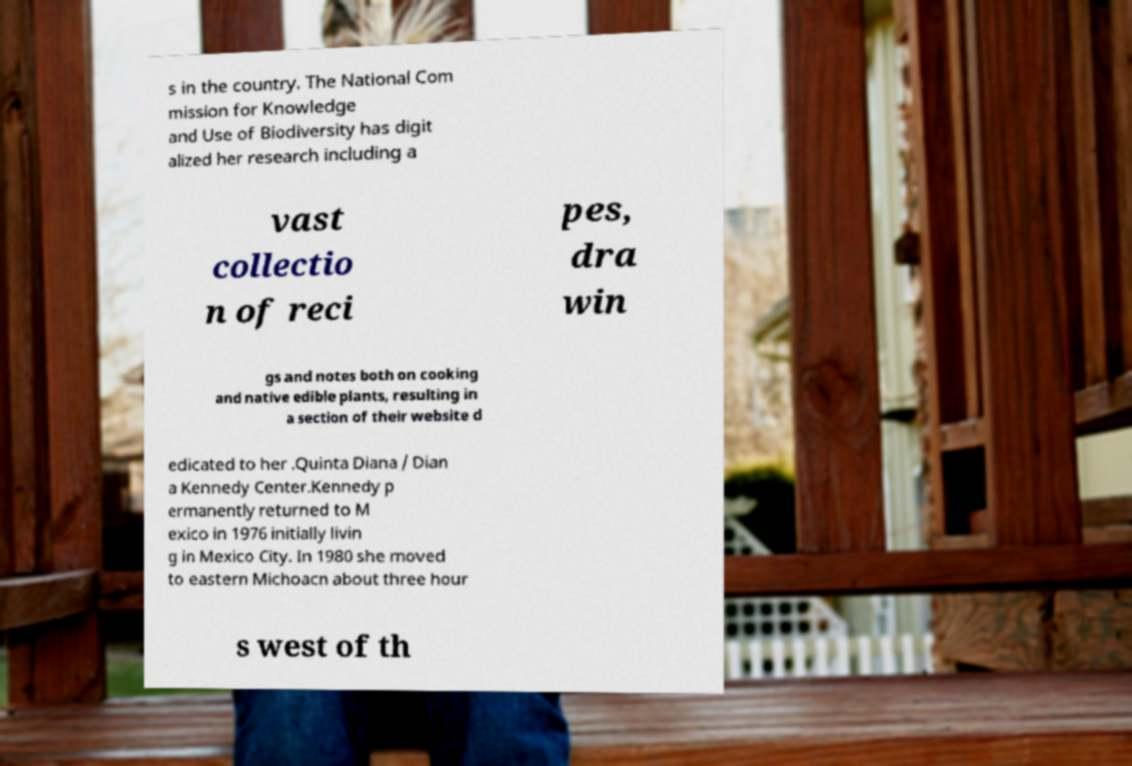For documentation purposes, I need the text within this image transcribed. Could you provide that? s in the country. The National Com mission for Knowledge and Use of Biodiversity has digit alized her research including a vast collectio n of reci pes, dra win gs and notes both on cooking and native edible plants, resulting in a section of their website d edicated to her .Quinta Diana / Dian a Kennedy Center.Kennedy p ermanently returned to M exico in 1976 initially livin g in Mexico City. In 1980 she moved to eastern Michoacn about three hour s west of th 